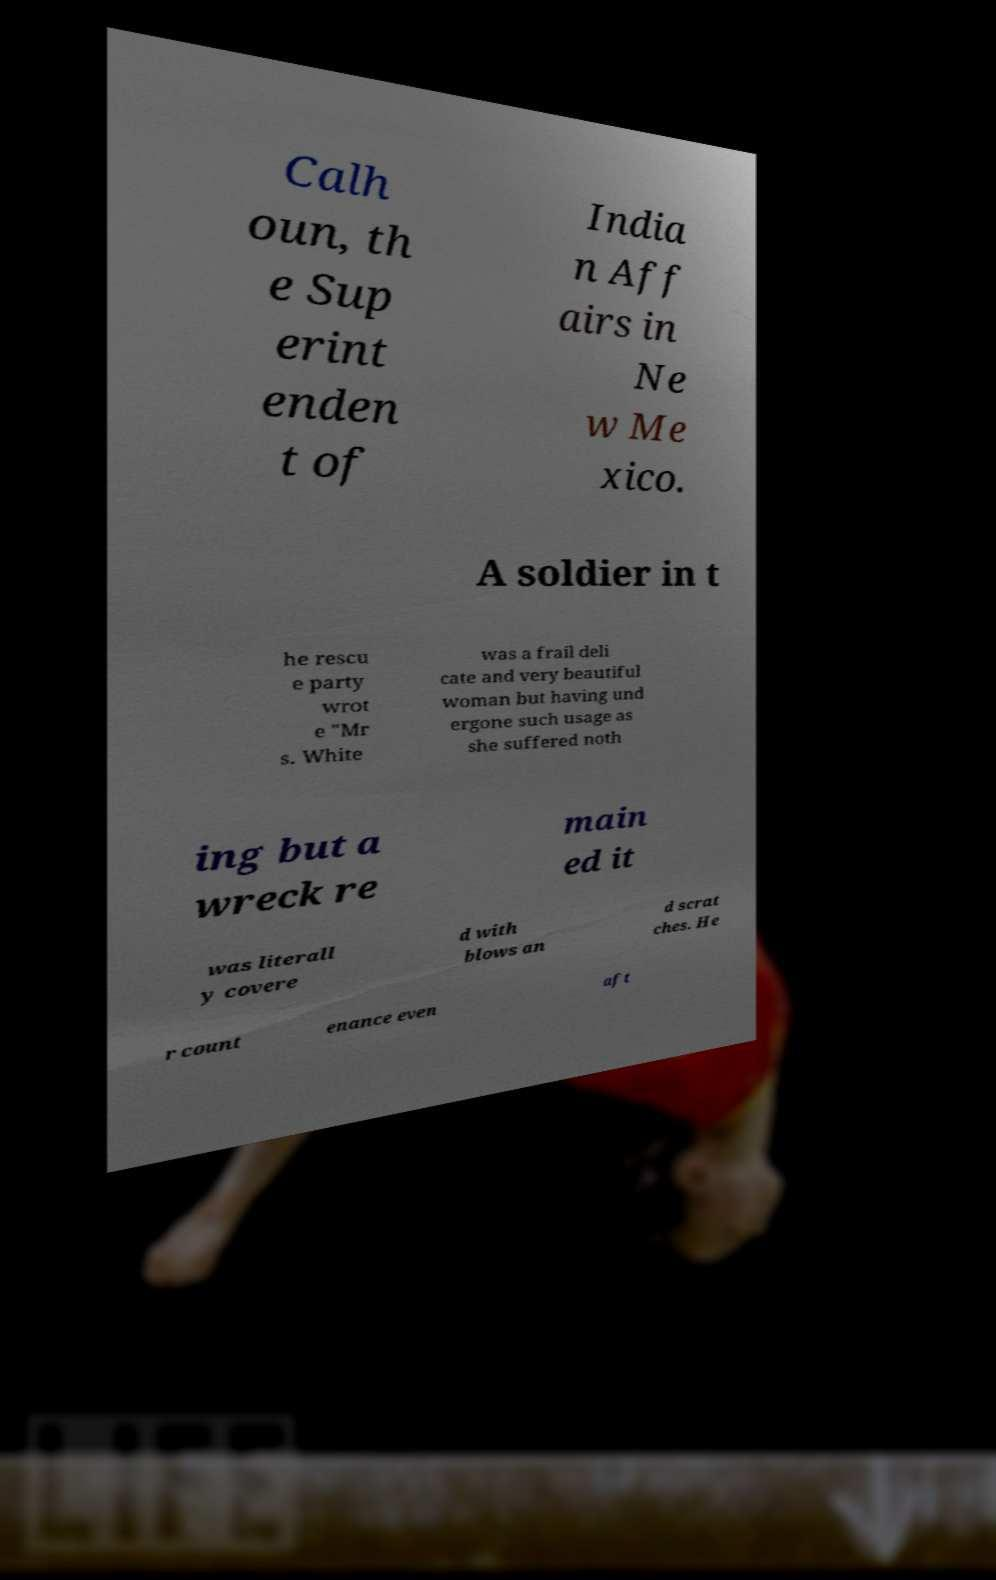Can you accurately transcribe the text from the provided image for me? Calh oun, th e Sup erint enden t of India n Aff airs in Ne w Me xico. A soldier in t he rescu e party wrot e "Mr s. White was a frail deli cate and very beautiful woman but having und ergone such usage as she suffered noth ing but a wreck re main ed it was literall y covere d with blows an d scrat ches. He r count enance even aft 